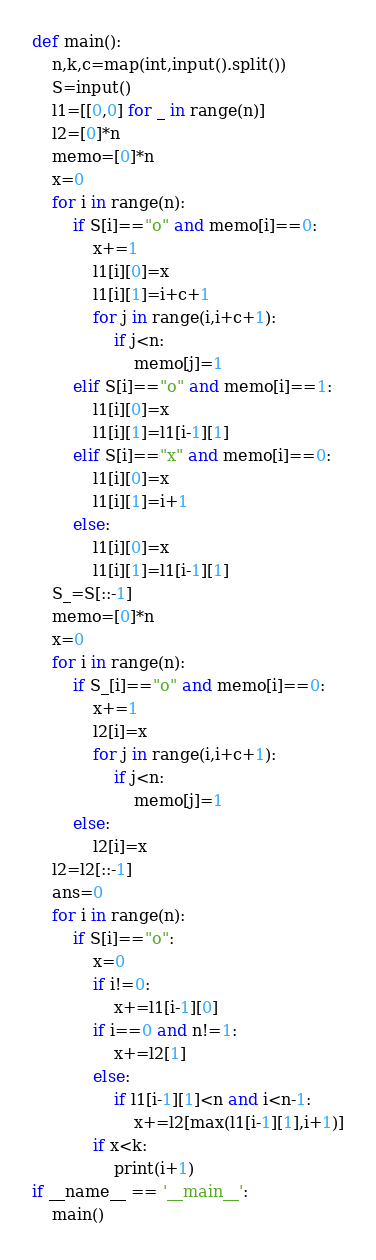Convert code to text. <code><loc_0><loc_0><loc_500><loc_500><_Python_>def main():
    n,k,c=map(int,input().split())
    S=input()
    l1=[[0,0] for _ in range(n)]
    l2=[0]*n
    memo=[0]*n
    x=0
    for i in range(n):
        if S[i]=="o" and memo[i]==0:
            x+=1
            l1[i][0]=x
            l1[i][1]=i+c+1
            for j in range(i,i+c+1):
                if j<n:
                    memo[j]=1
        elif S[i]=="o" and memo[i]==1:
            l1[i][0]=x
            l1[i][1]=l1[i-1][1]
        elif S[i]=="x" and memo[i]==0:
            l1[i][0]=x
            l1[i][1]=i+1
        else:
            l1[i][0]=x
            l1[i][1]=l1[i-1][1]
    S_=S[::-1]
    memo=[0]*n
    x=0
    for i in range(n):
        if S_[i]=="o" and memo[i]==0:
            x+=1
            l2[i]=x
            for j in range(i,i+c+1):
                if j<n:
                    memo[j]=1
        else:
            l2[i]=x
    l2=l2[::-1]
    ans=0
    for i in range(n):
        if S[i]=="o":
            x=0
            if i!=0:
                x+=l1[i-1][0]
            if i==0 and n!=1:
                x+=l2[1]
            else:
                if l1[i-1][1]<n and i<n-1:
                    x+=l2[max(l1[i-1][1],i+1)]
            if x<k:
                print(i+1)
if __name__ == '__main__':
    main()</code> 